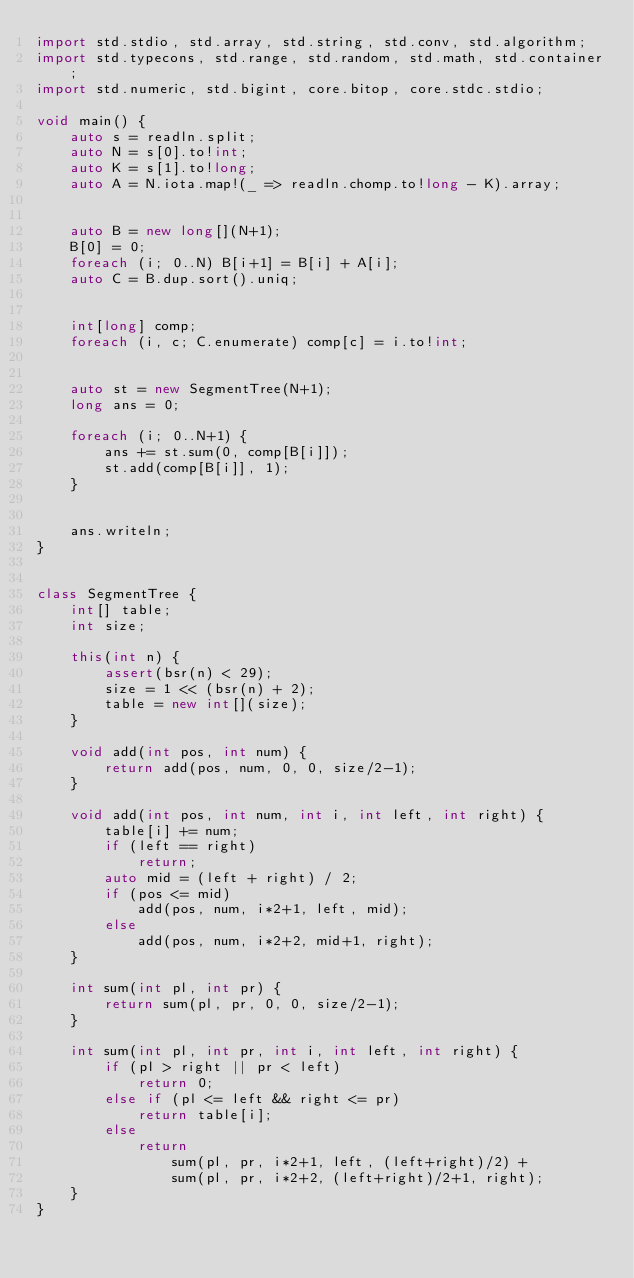Convert code to text. <code><loc_0><loc_0><loc_500><loc_500><_D_>import std.stdio, std.array, std.string, std.conv, std.algorithm;
import std.typecons, std.range, std.random, std.math, std.container;
import std.numeric, std.bigint, core.bitop, core.stdc.stdio;

void main() {
    auto s = readln.split;
    auto N = s[0].to!int;
    auto K = s[1].to!long;
    auto A = N.iota.map!(_ => readln.chomp.to!long - K).array;

    
    auto B = new long[](N+1);
    B[0] = 0;
    foreach (i; 0..N) B[i+1] = B[i] + A[i];
    auto C = B.dup.sort().uniq;

    
    int[long] comp;
    foreach (i, c; C.enumerate) comp[c] = i.to!int;

    
    auto st = new SegmentTree(N+1);
    long ans = 0;

    foreach (i; 0..N+1) {
        ans += st.sum(0, comp[B[i]]);
        st.add(comp[B[i]], 1);
    }


    ans.writeln;
}


class SegmentTree {
    int[] table;
    int size;

    this(int n) {
        assert(bsr(n) < 29);
        size = 1 << (bsr(n) + 2);
        table = new int[](size);
    }

    void add(int pos, int num) {
        return add(pos, num, 0, 0, size/2-1);
    }

    void add(int pos, int num, int i, int left, int right) {
        table[i] += num;
        if (left == right)
            return;
        auto mid = (left + right) / 2;
        if (pos <= mid)
            add(pos, num, i*2+1, left, mid);
        else
            add(pos, num, i*2+2, mid+1, right);
    }

    int sum(int pl, int pr) {
        return sum(pl, pr, 0, 0, size/2-1);
    }

    int sum(int pl, int pr, int i, int left, int right) {
        if (pl > right || pr < left)
            return 0;
        else if (pl <= left && right <= pr)
            return table[i];
        else
            return
                sum(pl, pr, i*2+1, left, (left+right)/2) +
                sum(pl, pr, i*2+2, (left+right)/2+1, right);
    }
}
</code> 